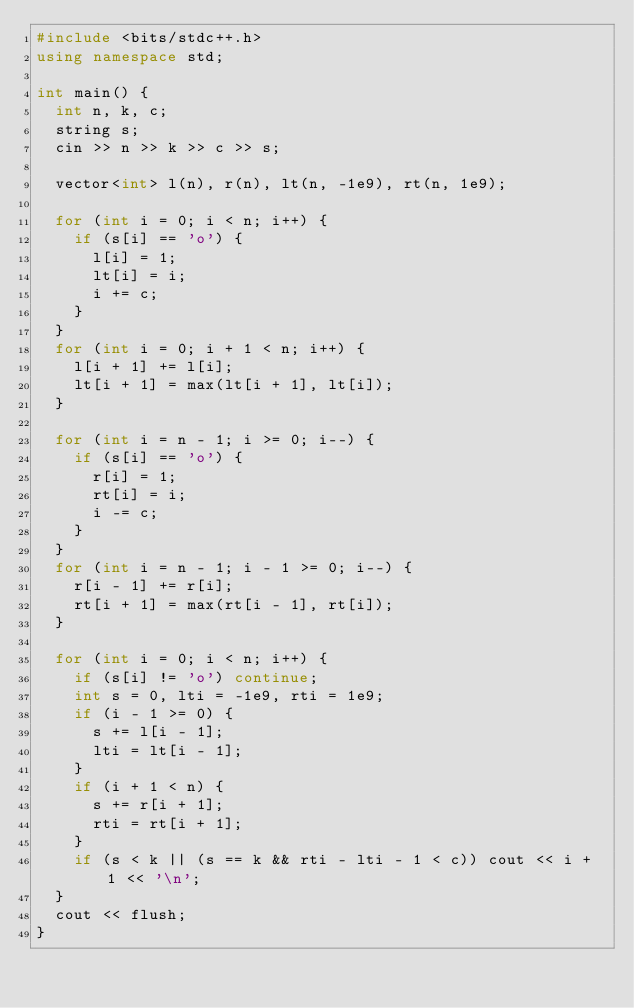Convert code to text. <code><loc_0><loc_0><loc_500><loc_500><_C++_>#include <bits/stdc++.h>
using namespace std;

int main() {
  int n, k, c;
  string s;
  cin >> n >> k >> c >> s;

  vector<int> l(n), r(n), lt(n, -1e9), rt(n, 1e9);

  for (int i = 0; i < n; i++) {
    if (s[i] == 'o') {
      l[i] = 1;
      lt[i] = i;
      i += c;
    }
  }
  for (int i = 0; i + 1 < n; i++) {
    l[i + 1] += l[i];
    lt[i + 1] = max(lt[i + 1], lt[i]);
  }

  for (int i = n - 1; i >= 0; i--) {
    if (s[i] == 'o') {
      r[i] = 1;
      rt[i] = i;
      i -= c;
    }
  }
  for (int i = n - 1; i - 1 >= 0; i--) {
    r[i - 1] += r[i];
    rt[i + 1] = max(rt[i - 1], rt[i]);
  }

  for (int i = 0; i < n; i++) {
    if (s[i] != 'o') continue;
    int s = 0, lti = -1e9, rti = 1e9;
    if (i - 1 >= 0) {
      s += l[i - 1];
      lti = lt[i - 1];
    }
    if (i + 1 < n) {
      s += r[i + 1];
      rti = rt[i + 1];
    }
    if (s < k || (s == k && rti - lti - 1 < c)) cout << i + 1 << '\n';
  }
  cout << flush;
}
</code> 